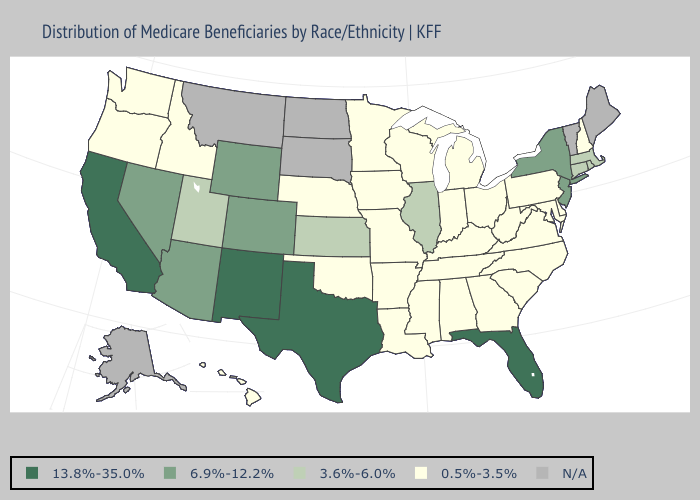Name the states that have a value in the range 0.5%-3.5%?
Be succinct. Alabama, Arkansas, Delaware, Georgia, Hawaii, Idaho, Indiana, Iowa, Kentucky, Louisiana, Maryland, Michigan, Minnesota, Mississippi, Missouri, Nebraska, New Hampshire, North Carolina, Ohio, Oklahoma, Oregon, Pennsylvania, South Carolina, Tennessee, Virginia, Washington, West Virginia, Wisconsin. Which states hav the highest value in the West?
Concise answer only. California, New Mexico. Among the states that border Nebraska , does Colorado have the lowest value?
Quick response, please. No. Among the states that border Arizona , which have the highest value?
Concise answer only. California, New Mexico. Does California have the highest value in the USA?
Be succinct. Yes. What is the value of Kentucky?
Quick response, please. 0.5%-3.5%. What is the highest value in the USA?
Quick response, please. 13.8%-35.0%. Does Arizona have the lowest value in the USA?
Be succinct. No. Which states have the lowest value in the MidWest?
Give a very brief answer. Indiana, Iowa, Michigan, Minnesota, Missouri, Nebraska, Ohio, Wisconsin. Name the states that have a value in the range 0.5%-3.5%?
Keep it brief. Alabama, Arkansas, Delaware, Georgia, Hawaii, Idaho, Indiana, Iowa, Kentucky, Louisiana, Maryland, Michigan, Minnesota, Mississippi, Missouri, Nebraska, New Hampshire, North Carolina, Ohio, Oklahoma, Oregon, Pennsylvania, South Carolina, Tennessee, Virginia, Washington, West Virginia, Wisconsin. Name the states that have a value in the range 13.8%-35.0%?
Answer briefly. California, Florida, New Mexico, Texas. What is the lowest value in the Northeast?
Quick response, please. 0.5%-3.5%. 